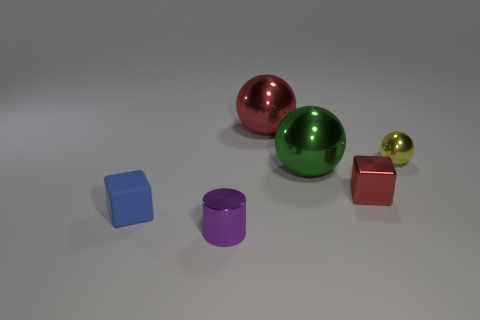Is there a purple thing made of the same material as the big red ball?
Keep it short and to the point. Yes. Are the red sphere and the green ball made of the same material?
Make the answer very short. Yes. The metal sphere that is the same size as the green shiny thing is what color?
Provide a short and direct response. Red. How many other things are the same shape as the small blue object?
Your response must be concise. 1. Does the purple shiny object have the same size as the cube left of the shiny cylinder?
Make the answer very short. Yes. What number of objects are either large cylinders or small metal objects?
Keep it short and to the point. 3. What number of other things are the same size as the green thing?
Keep it short and to the point. 1. Does the shiny cube have the same color as the big ball behind the yellow shiny sphere?
Ensure brevity in your answer.  Yes. What number of spheres are tiny blue rubber objects or shiny objects?
Keep it short and to the point. 3. Are there any other things that are the same color as the small shiny cylinder?
Keep it short and to the point. No. 